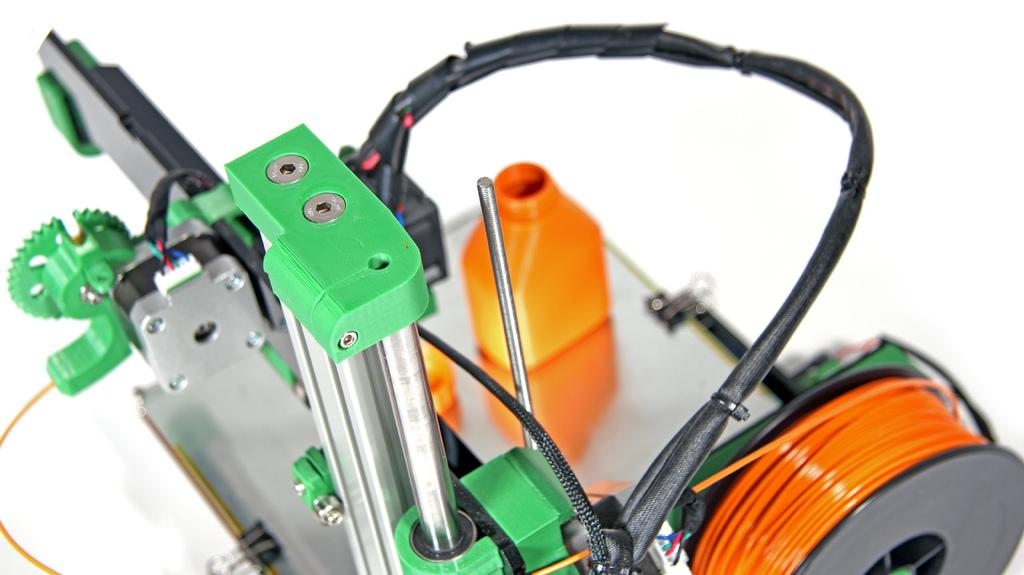What is the main object in the image? There is a machine in the image. What else can be seen in the image besides the machine? There is a bottle in the image. What color is the background of the image? The background of the image is white. What type of maid is depicted in the image? There is no maid present in the image. What force is being applied to the machine in the image? There is no force being applied to the machine in the image; it is stationary. 